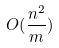Convert formula to latex. <formula><loc_0><loc_0><loc_500><loc_500>O ( \frac { n ^ { 2 } } { m } )</formula> 